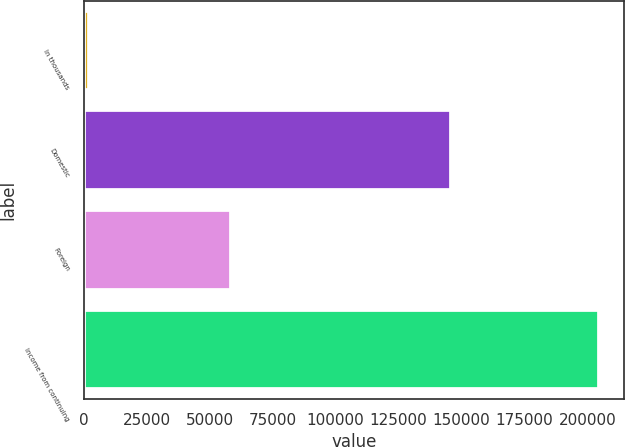<chart> <loc_0><loc_0><loc_500><loc_500><bar_chart><fcel>In thousands<fcel>Domestic<fcel>Foreign<fcel>Income from continuing<nl><fcel>2008<fcel>145791<fcel>58509<fcel>204300<nl></chart> 